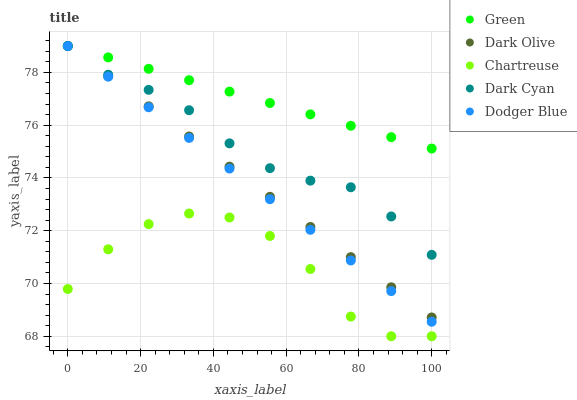Does Chartreuse have the minimum area under the curve?
Answer yes or no. Yes. Does Green have the maximum area under the curve?
Answer yes or no. Yes. Does Dodger Blue have the minimum area under the curve?
Answer yes or no. No. Does Dodger Blue have the maximum area under the curve?
Answer yes or no. No. Is Green the smoothest?
Answer yes or no. Yes. Is Chartreuse the roughest?
Answer yes or no. Yes. Is Dodger Blue the smoothest?
Answer yes or no. No. Is Dodger Blue the roughest?
Answer yes or no. No. Does Chartreuse have the lowest value?
Answer yes or no. Yes. Does Dodger Blue have the lowest value?
Answer yes or no. No. Does Green have the highest value?
Answer yes or no. Yes. Does Chartreuse have the highest value?
Answer yes or no. No. Is Chartreuse less than Dodger Blue?
Answer yes or no. Yes. Is Dark Olive greater than Chartreuse?
Answer yes or no. Yes. Does Green intersect Dark Cyan?
Answer yes or no. Yes. Is Green less than Dark Cyan?
Answer yes or no. No. Is Green greater than Dark Cyan?
Answer yes or no. No. Does Chartreuse intersect Dodger Blue?
Answer yes or no. No. 